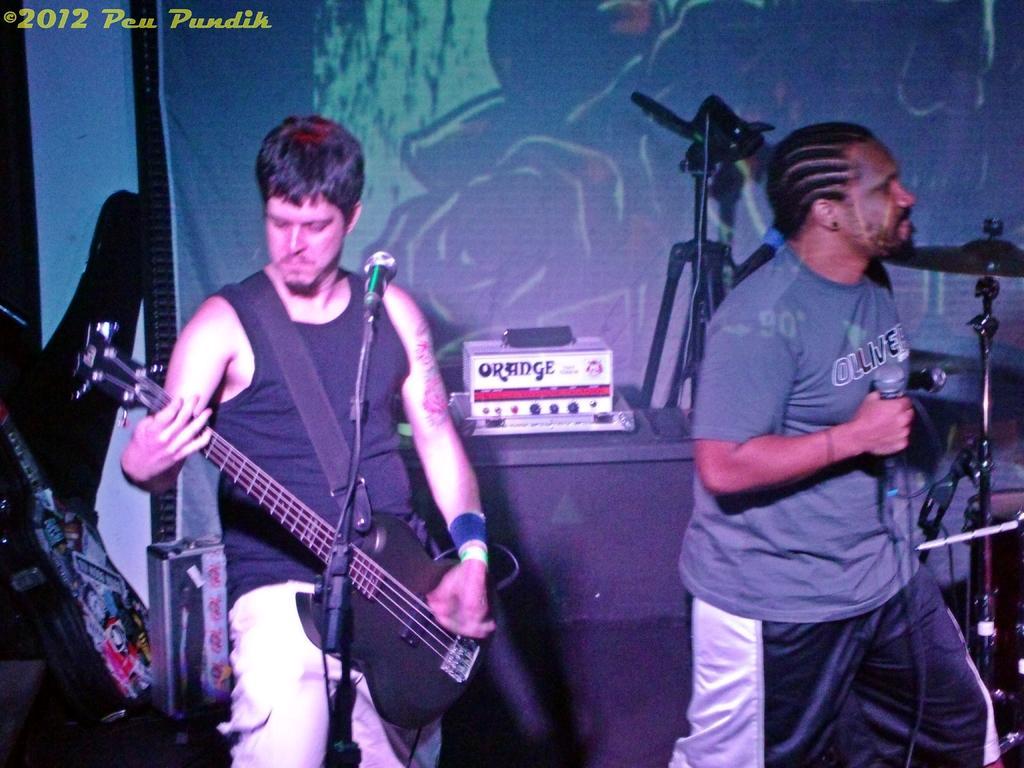Please provide a concise description of this image. In this picture we see a man playing guitar and a man standing by holding a microphone in his hand 